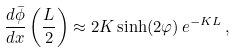Convert formula to latex. <formula><loc_0><loc_0><loc_500><loc_500>\frac { d { \bar { \phi } } } { d x } \left ( \frac { L } { 2 } \right ) \approx 2 K \sinh ( 2 \varphi ) \, e ^ { - K L } \, ,</formula> 